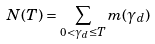<formula> <loc_0><loc_0><loc_500><loc_500>N ( T ) = \sum _ { 0 < \gamma _ { d } \leq T } m ( \gamma _ { d } )</formula> 